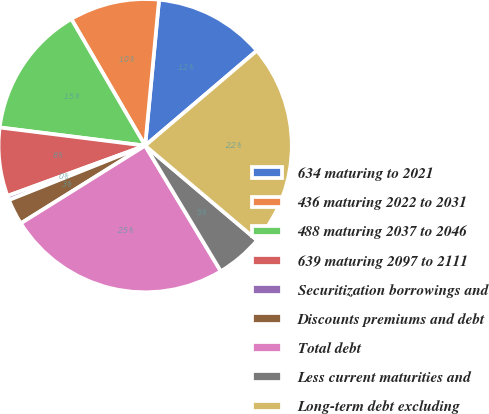Convert chart. <chart><loc_0><loc_0><loc_500><loc_500><pie_chart><fcel>634 maturing to 2021<fcel>436 maturing 2022 to 2031<fcel>488 maturing 2037 to 2046<fcel>639 maturing 2097 to 2111<fcel>Securitization borrowings and<fcel>Discounts premiums and debt<fcel>Total debt<fcel>Less current maturities and<fcel>Long-term debt excluding<nl><fcel>12.27%<fcel>9.91%<fcel>14.62%<fcel>7.55%<fcel>0.48%<fcel>2.84%<fcel>24.74%<fcel>5.2%<fcel>22.39%<nl></chart> 